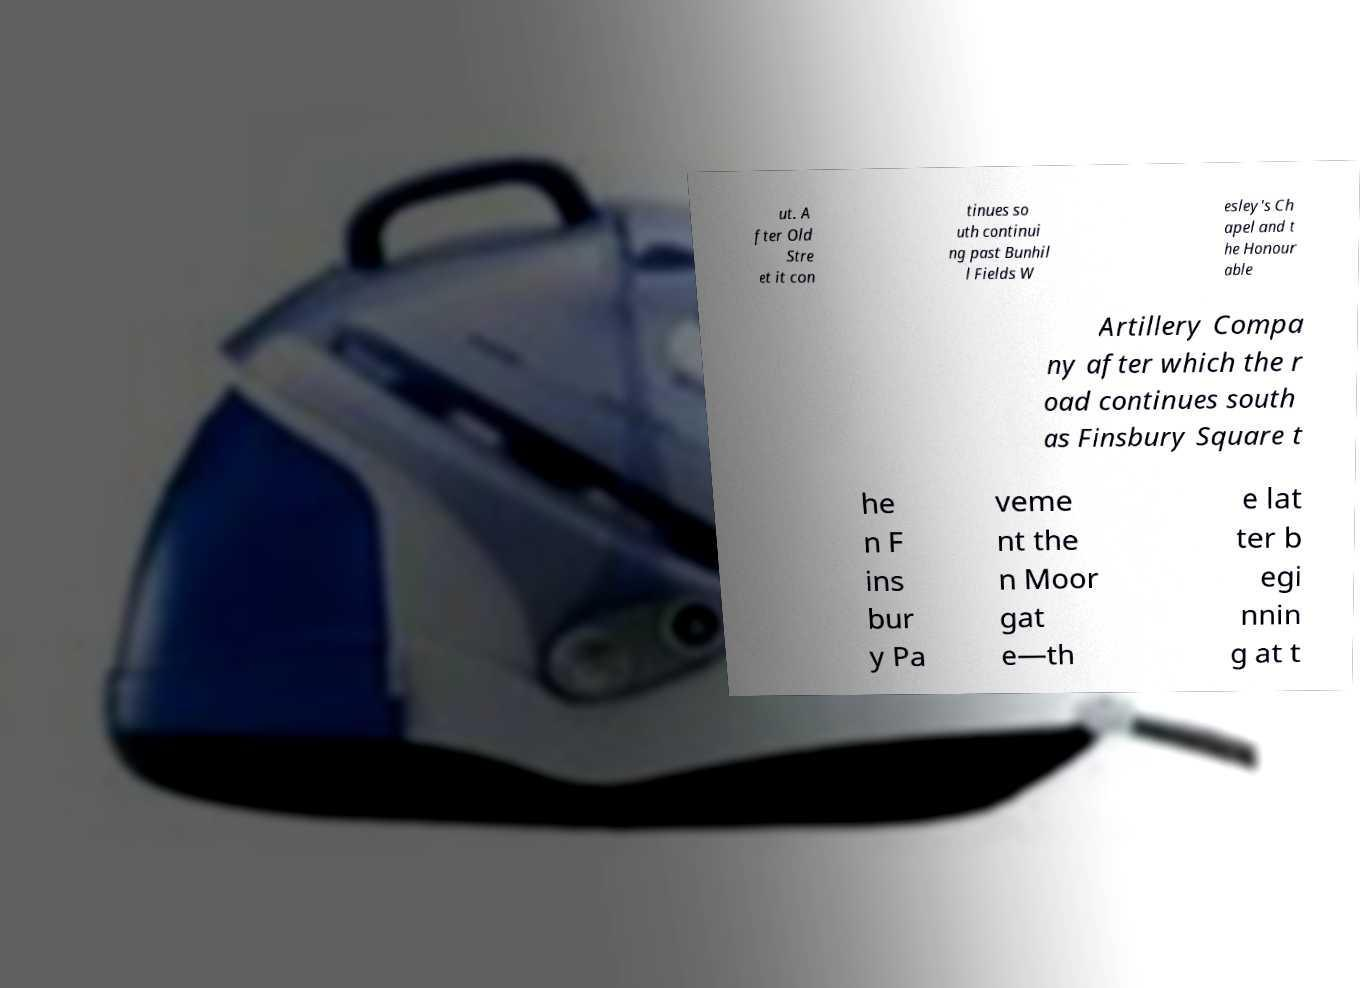What messages or text are displayed in this image? I need them in a readable, typed format. ut. A fter Old Stre et it con tinues so uth continui ng past Bunhil l Fields W esley's Ch apel and t he Honour able Artillery Compa ny after which the r oad continues south as Finsbury Square t he n F ins bur y Pa veme nt the n Moor gat e—th e lat ter b egi nnin g at t 